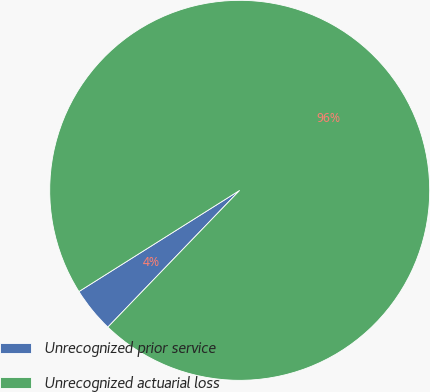<chart> <loc_0><loc_0><loc_500><loc_500><pie_chart><fcel>Unrecognized prior service<fcel>Unrecognized actuarial loss<nl><fcel>3.85%<fcel>96.15%<nl></chart> 